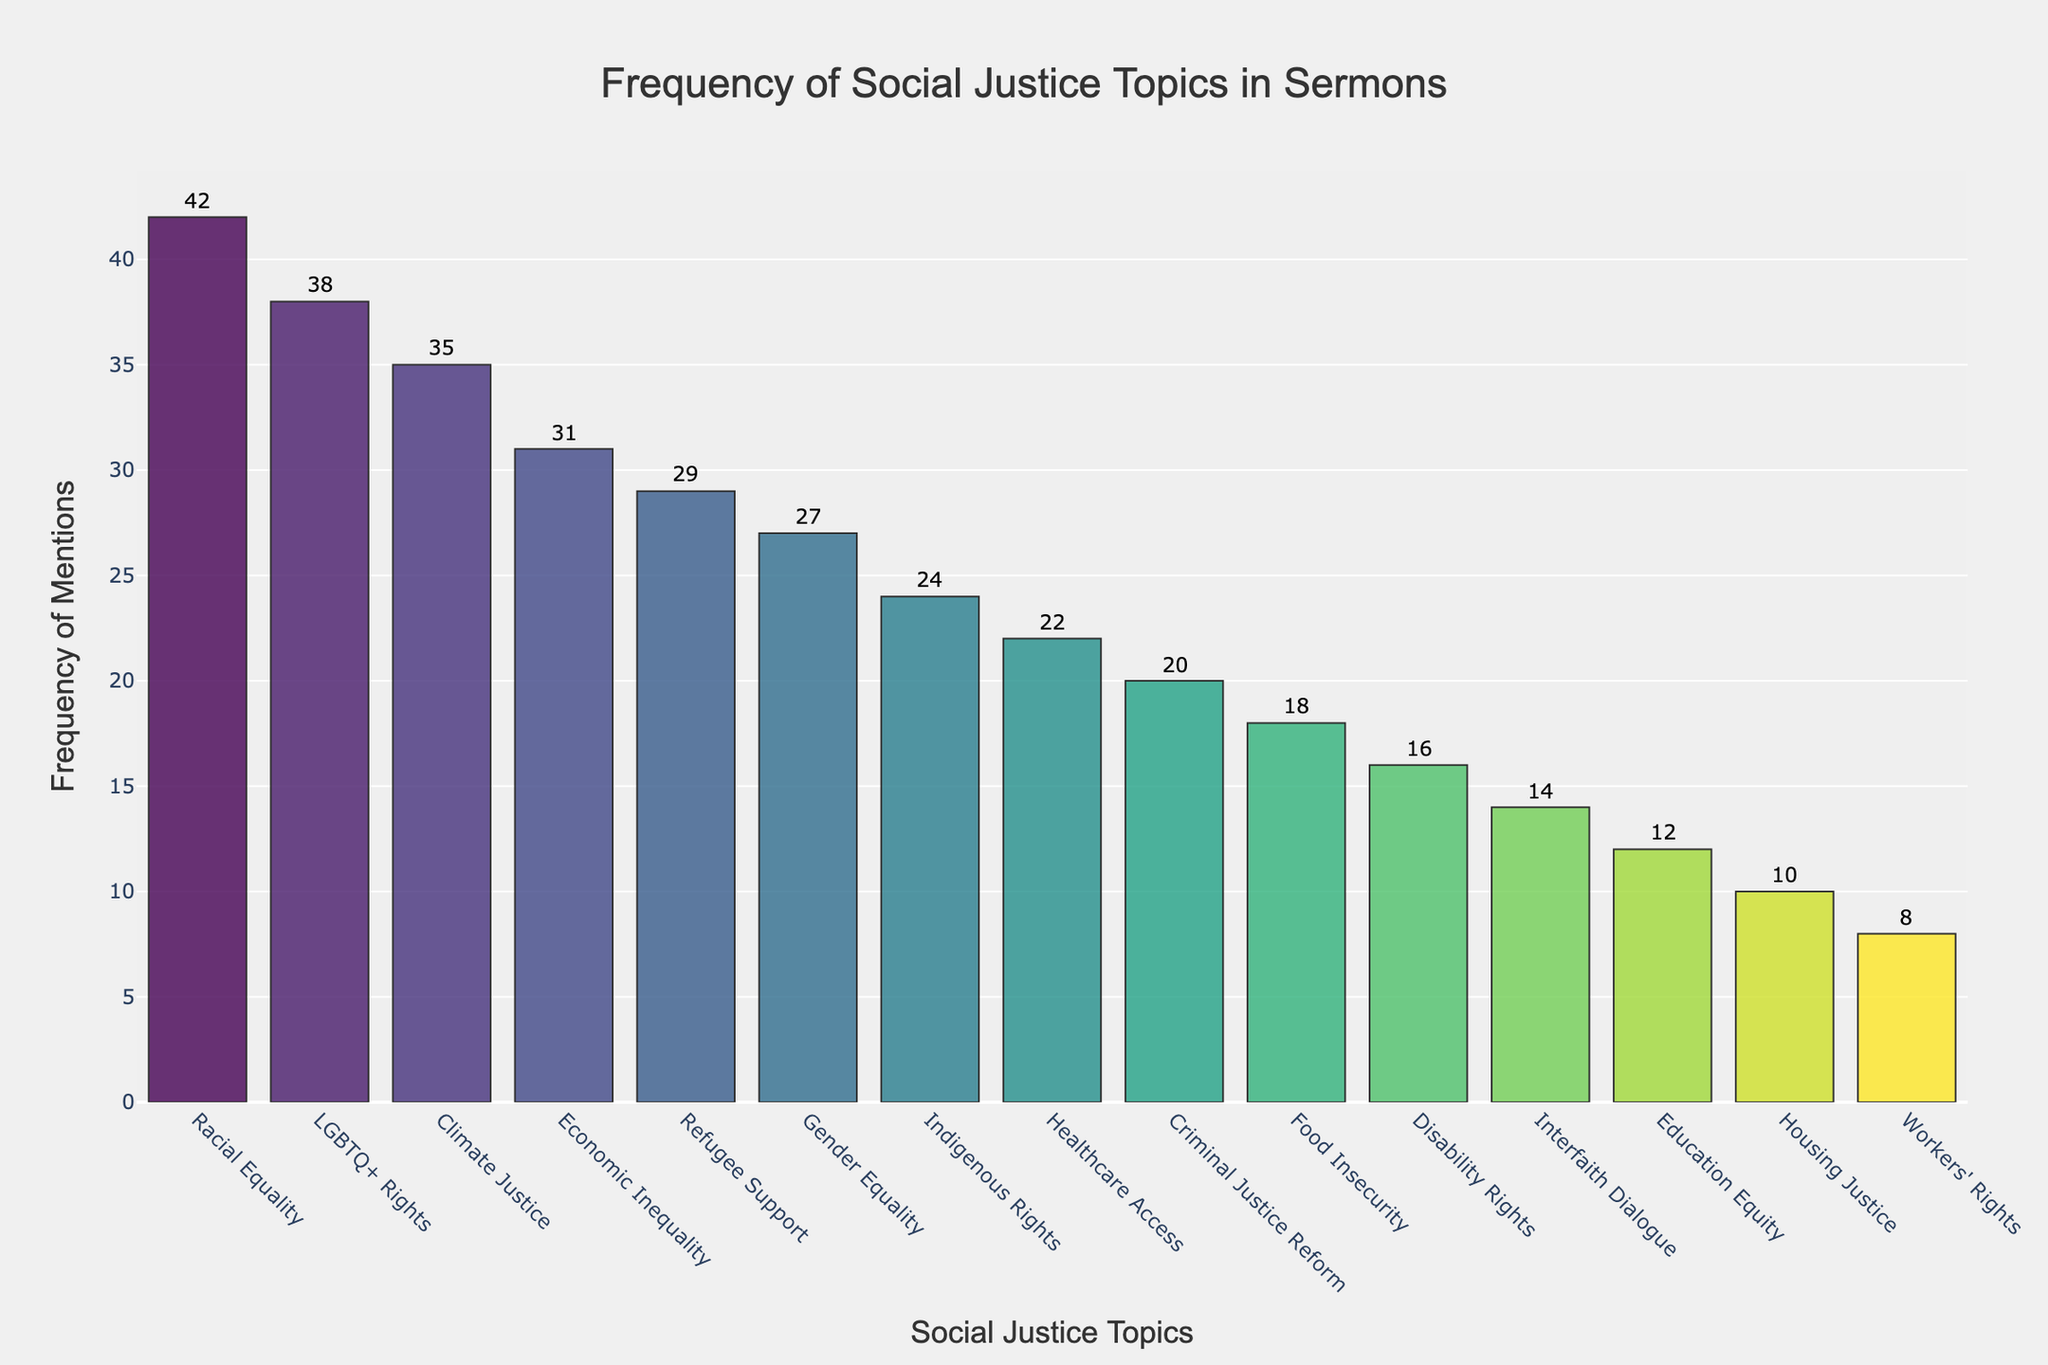what is the title of the figure? The title of the figure can be found at the top, centered in bold text. It provides an overview of what the plot represents.
Answer: Frequency of Social Justice Topics in Sermons How many topics are represented in the figure? To find the number of topics, count the bars in the histogram. Each bar represents one topic.
Answer: 15 which topic has the highest frequency of mentions? The topic with the highest bar represents the highest frequency. Upon examining the y-axis values, Racial Equality has the tallest bar.
Answer: Racial Equality what is the frequency of mentions for climate justice? Locate the bar for Climate Justice along the x-axis and read the corresponding frequency value from the y-axis.
Answer: 35 how many topics have a frequency of mentions greater than 30? Identify and count the bars that have a frequency value above 30 on the y-axis.
Answer: 4 Which topics have the same frequency of mentions? Compare the heights of the bars to see which ones are equal. Gender Equality and Indigenous Rights both have a bar height of 27 Frequency.
Answer: Gender Equality & Indigenous Rights What is the combined frequency of mentions for Education Equity and Workers' Rights? Find the frequency values for Education Equity and Workers' Rights, then add them together. Education Equity (12) + Workers' Rights (8) = 20.
Answer: 20 Are there more topics with a frequency above or below 20? Count the number of bars above and below the 20 marks on the y-axis. More topics have a frequency above 20 (9) compared to below 20 (6).
Answer: Above Which social justice topic has the least frequency of mentions? The topic with the shortest bar represents the least frequency. Workers' Rights has the shortest bar.
Answer: Workers' Rights 